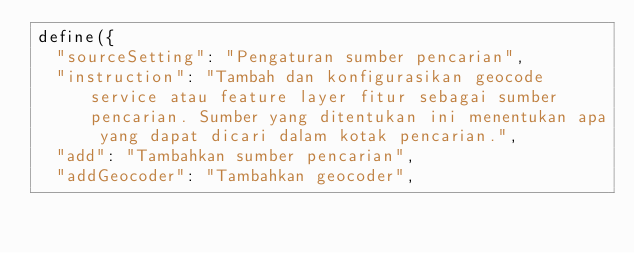<code> <loc_0><loc_0><loc_500><loc_500><_JavaScript_>define({
  "sourceSetting": "Pengaturan sumber pencarian",
  "instruction": "Tambah dan konfigurasikan geocode service atau feature layer fitur sebagai sumber pencarian. Sumber yang ditentukan ini menentukan apa yang dapat dicari dalam kotak pencarian.",
  "add": "Tambahkan sumber pencarian",
  "addGeocoder": "Tambahkan geocoder",</code> 